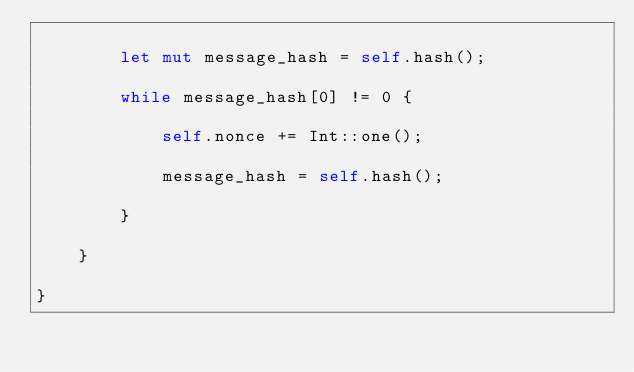<code> <loc_0><loc_0><loc_500><loc_500><_Rust_>
        let mut message_hash = self.hash();
        
        while message_hash[0] != 0 {

            self.nonce += Int::one();

            message_hash = self.hash();

        }

    }

}</code> 